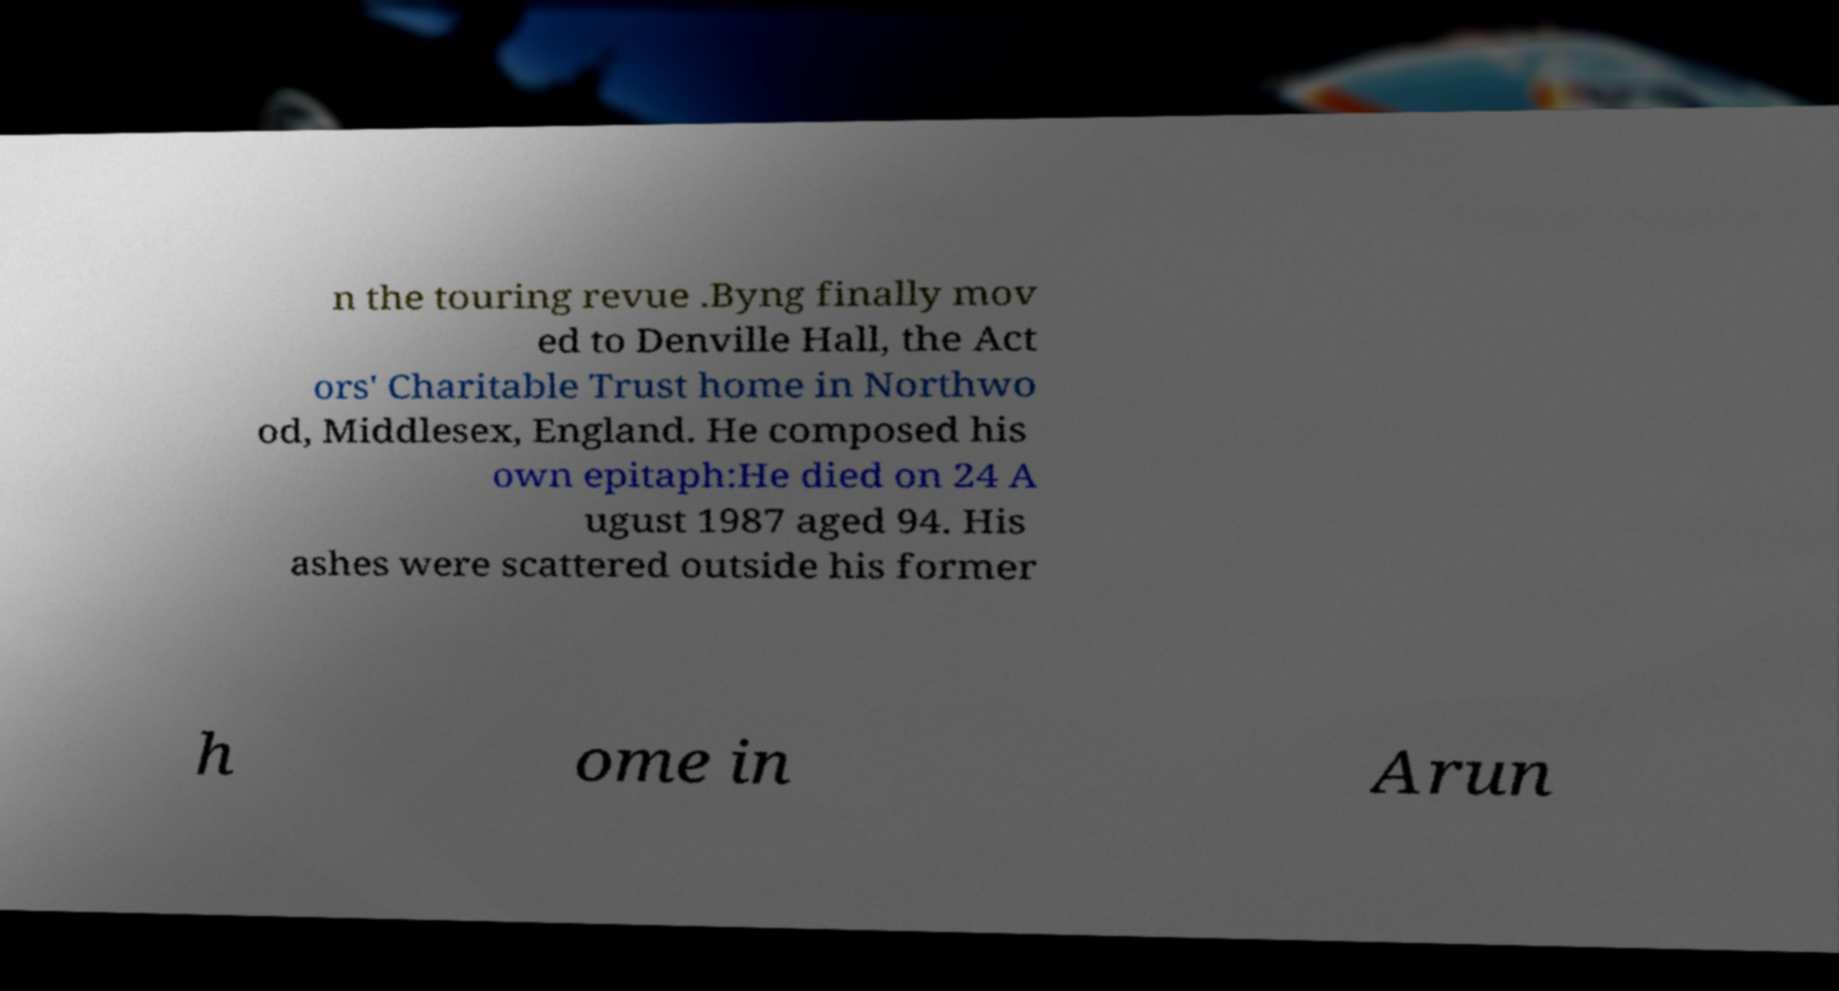Could you extract and type out the text from this image? n the touring revue .Byng finally mov ed to Denville Hall, the Act ors' Charitable Trust home in Northwo od, Middlesex, England. He composed his own epitaph:He died on 24 A ugust 1987 aged 94. His ashes were scattered outside his former h ome in Arun 